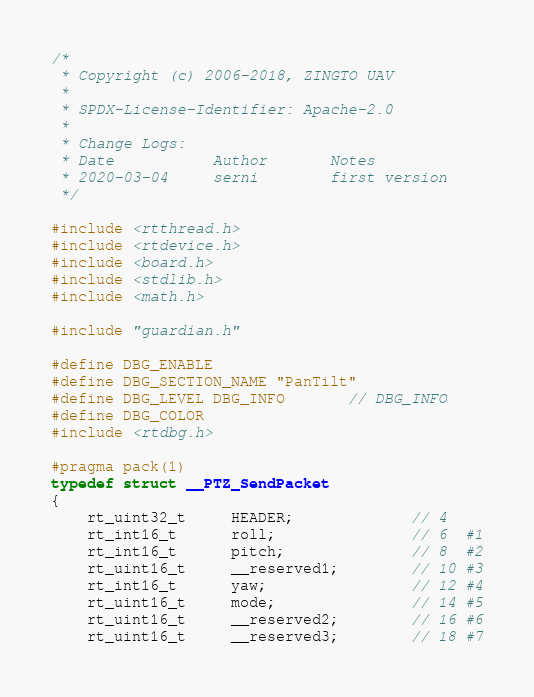Convert code to text. <code><loc_0><loc_0><loc_500><loc_500><_C_>/*
 * Copyright (c) 2006-2018, ZINGTO UAV
 *
 * SPDX-License-Identifier: Apache-2.0
 *
 * Change Logs:
 * Date           Author       Notes
 * 2020-03-04     serni        first version
 */

#include <rtthread.h>
#include <rtdevice.h>
#include <board.h>
#include <stdlib.h>
#include <math.h>

#include "guardian.h"

#define DBG_ENABLE
#define DBG_SECTION_NAME "PanTilt"
#define DBG_LEVEL DBG_INFO       // DBG_INFO
#define DBG_COLOR
#include <rtdbg.h>

#pragma pack(1)
typedef struct __PTZ_SendPacket
{
    rt_uint32_t     HEADER;             // 4
    rt_int16_t      roll;               // 6  #1
    rt_int16_t      pitch;              // 8  #2
    rt_uint16_t     __reserved1;        // 10 #3
    rt_int16_t      yaw;                // 12 #4
    rt_uint16_t     mode;               // 14 #5
    rt_uint16_t     __reserved2;        // 16 #6
    rt_uint16_t     __reserved3;        // 18 #7</code> 